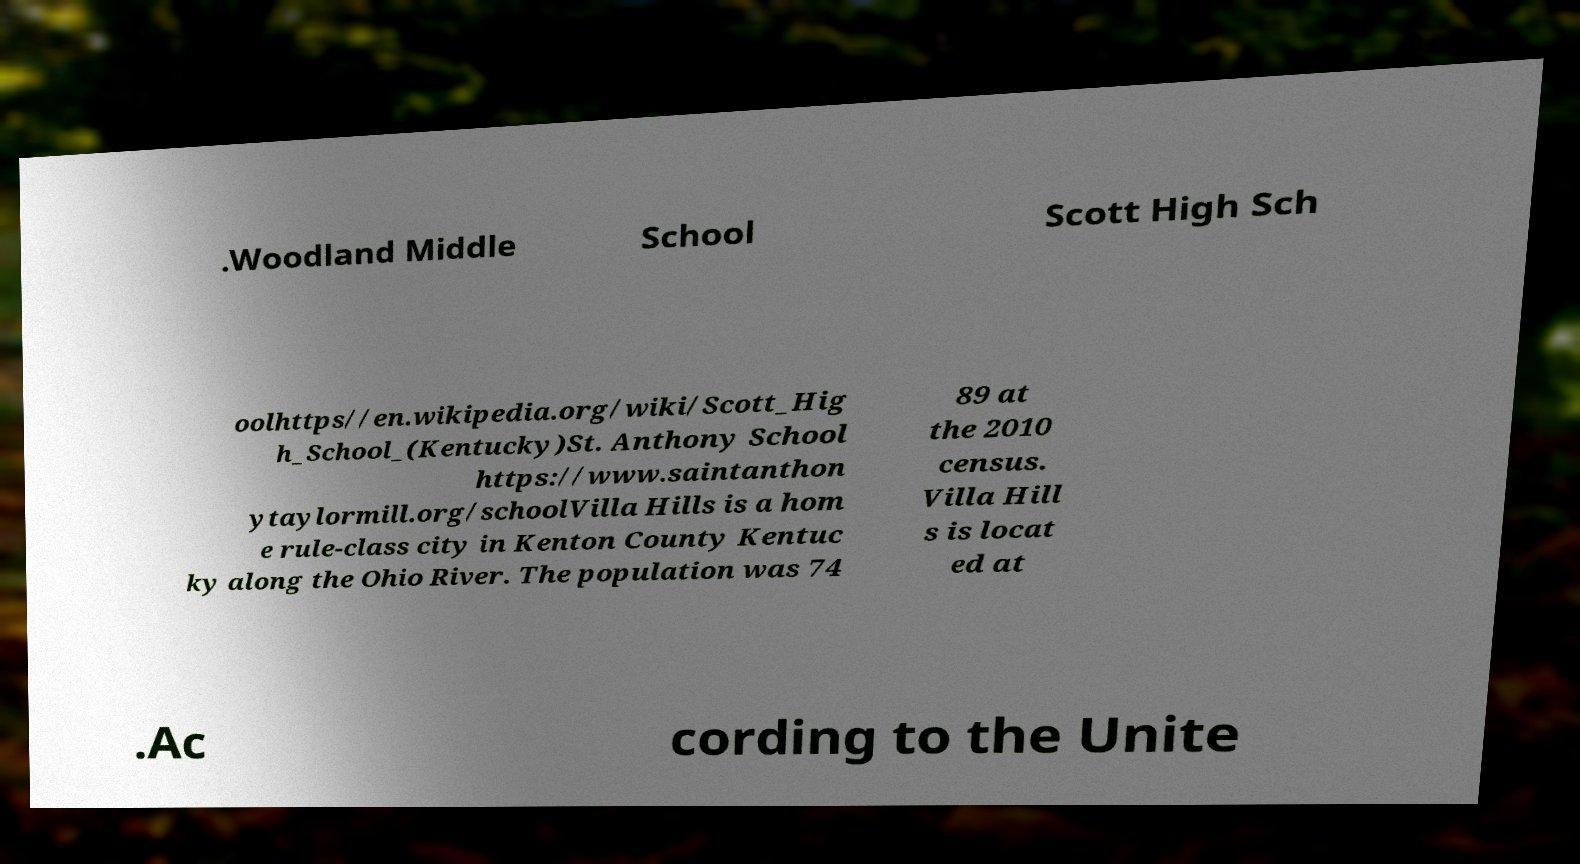What messages or text are displayed in this image? I need them in a readable, typed format. .Woodland Middle School Scott High Sch oolhttps//en.wikipedia.org/wiki/Scott_Hig h_School_(Kentucky)St. Anthony School https://www.saintanthon ytaylormill.org/schoolVilla Hills is a hom e rule-class city in Kenton County Kentuc ky along the Ohio River. The population was 74 89 at the 2010 census. Villa Hill s is locat ed at .Ac cording to the Unite 